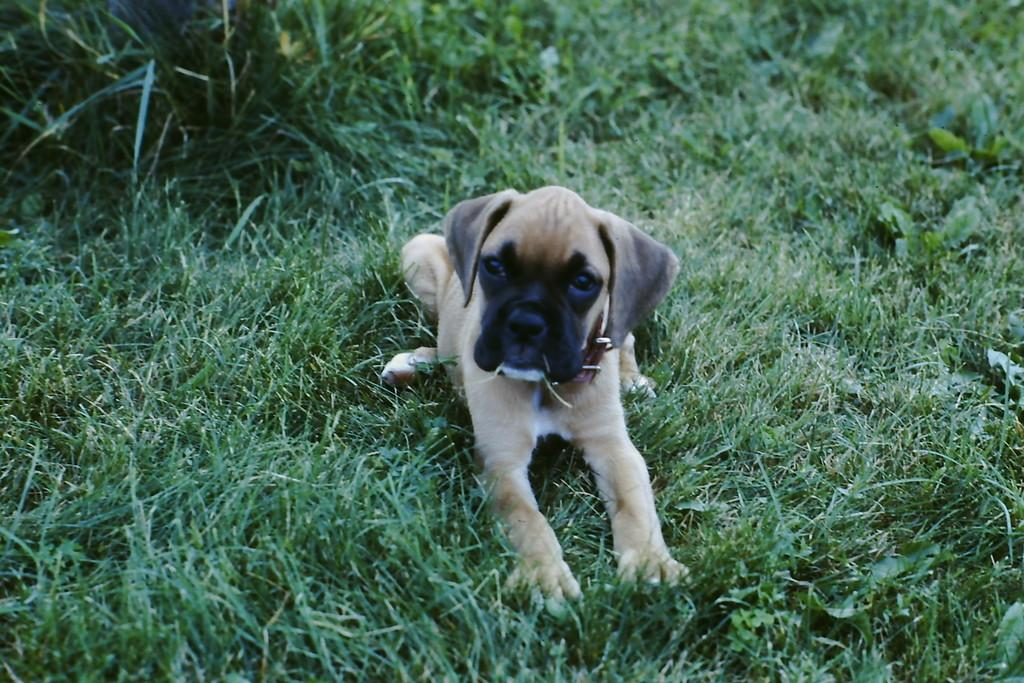What type of animal is present in the image? There is a dog in the image. What type of natural environment is visible in the image? There is grass in the image. What advice does the dog's father give to the dog in the image? There is no mention of a dog's father in the image, as the focus is on the dog and the grass. What facial expression does the dog have in the image? The facts provided do not mention the dog's facial expression, so it cannot be determined from the image. 